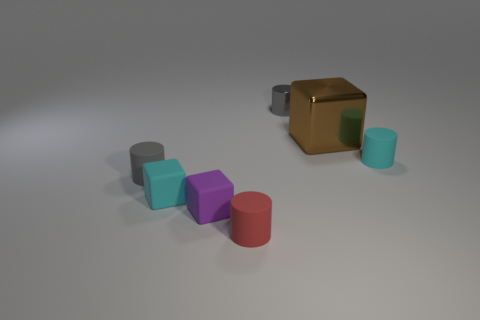Add 2 small green metal blocks. How many objects exist? 9 Subtract all blocks. How many objects are left? 4 Subtract all yellow rubber cubes. Subtract all brown shiny things. How many objects are left? 6 Add 4 big objects. How many big objects are left? 5 Add 5 large brown things. How many large brown things exist? 6 Subtract 0 gray balls. How many objects are left? 7 